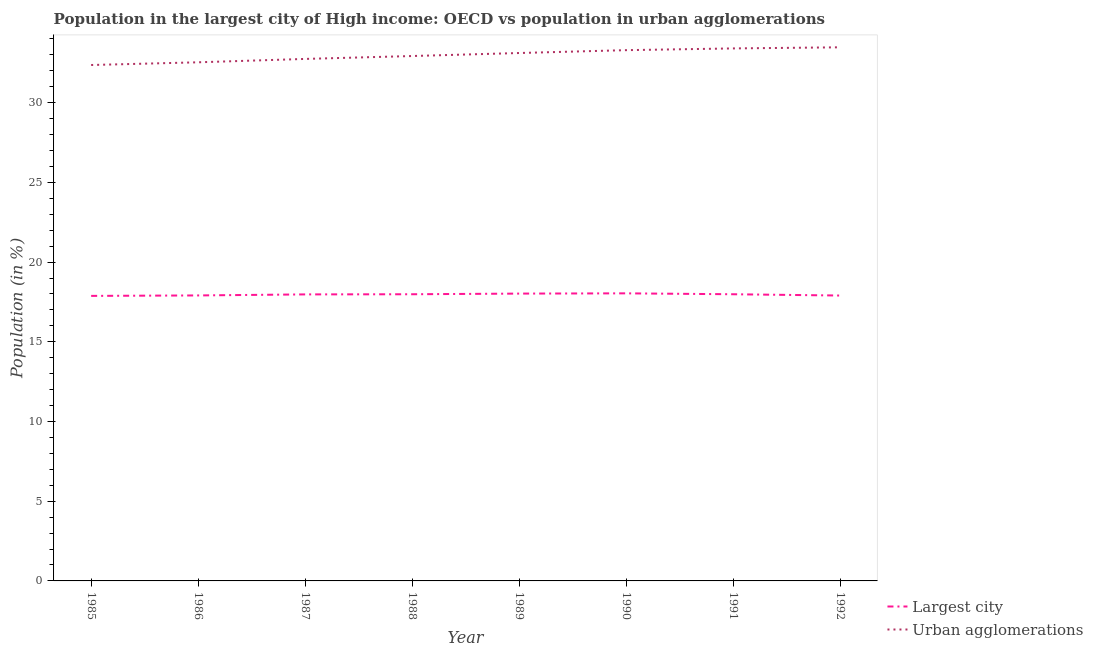Is the number of lines equal to the number of legend labels?
Provide a short and direct response. Yes. What is the population in urban agglomerations in 1985?
Ensure brevity in your answer.  32.36. Across all years, what is the maximum population in urban agglomerations?
Give a very brief answer. 33.48. Across all years, what is the minimum population in the largest city?
Provide a succinct answer. 17.88. What is the total population in the largest city in the graph?
Provide a succinct answer. 143.7. What is the difference between the population in urban agglomerations in 1989 and that in 1991?
Provide a succinct answer. -0.29. What is the difference between the population in the largest city in 1991 and the population in urban agglomerations in 1985?
Your answer should be compact. -14.38. What is the average population in urban agglomerations per year?
Your response must be concise. 32.98. In the year 1990, what is the difference between the population in urban agglomerations and population in the largest city?
Ensure brevity in your answer.  15.26. In how many years, is the population in urban agglomerations greater than 29 %?
Offer a very short reply. 8. What is the ratio of the population in urban agglomerations in 1985 to that in 1988?
Your response must be concise. 0.98. Is the population in the largest city in 1986 less than that in 1988?
Provide a succinct answer. Yes. Is the difference between the population in the largest city in 1985 and 1991 greater than the difference between the population in urban agglomerations in 1985 and 1991?
Your answer should be compact. Yes. What is the difference between the highest and the second highest population in urban agglomerations?
Your response must be concise. 0.07. What is the difference between the highest and the lowest population in the largest city?
Your response must be concise. 0.16. In how many years, is the population in the largest city greater than the average population in the largest city taken over all years?
Offer a terse response. 5. Is the sum of the population in urban agglomerations in 1990 and 1992 greater than the maximum population in the largest city across all years?
Keep it short and to the point. Yes. Is the population in the largest city strictly greater than the population in urban agglomerations over the years?
Keep it short and to the point. No. Is the population in the largest city strictly less than the population in urban agglomerations over the years?
Provide a succinct answer. Yes. How many lines are there?
Provide a short and direct response. 2. Does the graph contain grids?
Your response must be concise. No. Where does the legend appear in the graph?
Provide a succinct answer. Bottom right. How many legend labels are there?
Keep it short and to the point. 2. How are the legend labels stacked?
Give a very brief answer. Vertical. What is the title of the graph?
Offer a very short reply. Population in the largest city of High income: OECD vs population in urban agglomerations. Does "Rural Population" appear as one of the legend labels in the graph?
Your response must be concise. No. What is the Population (in %) of Largest city in 1985?
Give a very brief answer. 17.88. What is the Population (in %) in Urban agglomerations in 1985?
Keep it short and to the point. 32.36. What is the Population (in %) of Largest city in 1986?
Your answer should be compact. 17.91. What is the Population (in %) of Urban agglomerations in 1986?
Give a very brief answer. 32.53. What is the Population (in %) of Largest city in 1987?
Give a very brief answer. 17.97. What is the Population (in %) of Urban agglomerations in 1987?
Ensure brevity in your answer.  32.75. What is the Population (in %) in Largest city in 1988?
Ensure brevity in your answer.  17.98. What is the Population (in %) of Urban agglomerations in 1988?
Ensure brevity in your answer.  32.93. What is the Population (in %) of Largest city in 1989?
Give a very brief answer. 18.02. What is the Population (in %) of Urban agglomerations in 1989?
Provide a short and direct response. 33.12. What is the Population (in %) in Largest city in 1990?
Provide a succinct answer. 18.04. What is the Population (in %) in Urban agglomerations in 1990?
Your answer should be compact. 33.3. What is the Population (in %) in Largest city in 1991?
Give a very brief answer. 17.98. What is the Population (in %) in Urban agglomerations in 1991?
Offer a terse response. 33.41. What is the Population (in %) in Largest city in 1992?
Give a very brief answer. 17.9. What is the Population (in %) in Urban agglomerations in 1992?
Make the answer very short. 33.48. Across all years, what is the maximum Population (in %) in Largest city?
Make the answer very short. 18.04. Across all years, what is the maximum Population (in %) of Urban agglomerations?
Give a very brief answer. 33.48. Across all years, what is the minimum Population (in %) in Largest city?
Your answer should be compact. 17.88. Across all years, what is the minimum Population (in %) in Urban agglomerations?
Offer a very short reply. 32.36. What is the total Population (in %) of Largest city in the graph?
Provide a short and direct response. 143.7. What is the total Population (in %) in Urban agglomerations in the graph?
Your answer should be very brief. 263.87. What is the difference between the Population (in %) of Largest city in 1985 and that in 1986?
Ensure brevity in your answer.  -0.03. What is the difference between the Population (in %) of Urban agglomerations in 1985 and that in 1986?
Offer a very short reply. -0.17. What is the difference between the Population (in %) in Largest city in 1985 and that in 1987?
Give a very brief answer. -0.09. What is the difference between the Population (in %) in Urban agglomerations in 1985 and that in 1987?
Your response must be concise. -0.38. What is the difference between the Population (in %) of Largest city in 1985 and that in 1988?
Ensure brevity in your answer.  -0.1. What is the difference between the Population (in %) in Urban agglomerations in 1985 and that in 1988?
Provide a succinct answer. -0.56. What is the difference between the Population (in %) of Largest city in 1985 and that in 1989?
Provide a succinct answer. -0.14. What is the difference between the Population (in %) in Urban agglomerations in 1985 and that in 1989?
Provide a short and direct response. -0.75. What is the difference between the Population (in %) in Largest city in 1985 and that in 1990?
Your answer should be very brief. -0.16. What is the difference between the Population (in %) of Urban agglomerations in 1985 and that in 1990?
Your response must be concise. -0.93. What is the difference between the Population (in %) of Largest city in 1985 and that in 1991?
Offer a very short reply. -0.1. What is the difference between the Population (in %) in Urban agglomerations in 1985 and that in 1991?
Your response must be concise. -1.04. What is the difference between the Population (in %) in Largest city in 1985 and that in 1992?
Provide a succinct answer. -0.02. What is the difference between the Population (in %) of Urban agglomerations in 1985 and that in 1992?
Your answer should be compact. -1.11. What is the difference between the Population (in %) of Largest city in 1986 and that in 1987?
Give a very brief answer. -0.06. What is the difference between the Population (in %) of Urban agglomerations in 1986 and that in 1987?
Keep it short and to the point. -0.21. What is the difference between the Population (in %) of Largest city in 1986 and that in 1988?
Your answer should be compact. -0.07. What is the difference between the Population (in %) of Urban agglomerations in 1986 and that in 1988?
Your answer should be very brief. -0.39. What is the difference between the Population (in %) of Largest city in 1986 and that in 1989?
Keep it short and to the point. -0.12. What is the difference between the Population (in %) of Urban agglomerations in 1986 and that in 1989?
Provide a short and direct response. -0.58. What is the difference between the Population (in %) in Largest city in 1986 and that in 1990?
Provide a short and direct response. -0.13. What is the difference between the Population (in %) of Urban agglomerations in 1986 and that in 1990?
Offer a terse response. -0.76. What is the difference between the Population (in %) of Largest city in 1986 and that in 1991?
Your response must be concise. -0.07. What is the difference between the Population (in %) of Urban agglomerations in 1986 and that in 1991?
Provide a succinct answer. -0.87. What is the difference between the Population (in %) of Largest city in 1986 and that in 1992?
Provide a succinct answer. 0.01. What is the difference between the Population (in %) of Urban agglomerations in 1986 and that in 1992?
Offer a very short reply. -0.94. What is the difference between the Population (in %) of Largest city in 1987 and that in 1988?
Give a very brief answer. -0.01. What is the difference between the Population (in %) in Urban agglomerations in 1987 and that in 1988?
Keep it short and to the point. -0.18. What is the difference between the Population (in %) in Largest city in 1987 and that in 1989?
Offer a very short reply. -0.05. What is the difference between the Population (in %) of Urban agglomerations in 1987 and that in 1989?
Provide a succinct answer. -0.37. What is the difference between the Population (in %) of Largest city in 1987 and that in 1990?
Your answer should be compact. -0.07. What is the difference between the Population (in %) of Urban agglomerations in 1987 and that in 1990?
Keep it short and to the point. -0.55. What is the difference between the Population (in %) of Largest city in 1987 and that in 1991?
Your answer should be compact. -0.01. What is the difference between the Population (in %) of Urban agglomerations in 1987 and that in 1991?
Your answer should be compact. -0.66. What is the difference between the Population (in %) in Largest city in 1987 and that in 1992?
Offer a terse response. 0.07. What is the difference between the Population (in %) of Urban agglomerations in 1987 and that in 1992?
Offer a terse response. -0.73. What is the difference between the Population (in %) of Largest city in 1988 and that in 1989?
Your answer should be compact. -0.04. What is the difference between the Population (in %) of Urban agglomerations in 1988 and that in 1989?
Make the answer very short. -0.19. What is the difference between the Population (in %) in Largest city in 1988 and that in 1990?
Offer a terse response. -0.06. What is the difference between the Population (in %) in Urban agglomerations in 1988 and that in 1990?
Your response must be concise. -0.37. What is the difference between the Population (in %) of Largest city in 1988 and that in 1991?
Keep it short and to the point. -0. What is the difference between the Population (in %) of Urban agglomerations in 1988 and that in 1991?
Your answer should be very brief. -0.48. What is the difference between the Population (in %) in Largest city in 1988 and that in 1992?
Give a very brief answer. 0.08. What is the difference between the Population (in %) of Urban agglomerations in 1988 and that in 1992?
Provide a short and direct response. -0.55. What is the difference between the Population (in %) in Largest city in 1989 and that in 1990?
Provide a short and direct response. -0.02. What is the difference between the Population (in %) of Urban agglomerations in 1989 and that in 1990?
Provide a succinct answer. -0.18. What is the difference between the Population (in %) of Largest city in 1989 and that in 1991?
Keep it short and to the point. 0.04. What is the difference between the Population (in %) in Urban agglomerations in 1989 and that in 1991?
Make the answer very short. -0.29. What is the difference between the Population (in %) of Largest city in 1989 and that in 1992?
Ensure brevity in your answer.  0.12. What is the difference between the Population (in %) in Urban agglomerations in 1989 and that in 1992?
Keep it short and to the point. -0.36. What is the difference between the Population (in %) of Largest city in 1990 and that in 1991?
Your answer should be very brief. 0.06. What is the difference between the Population (in %) of Urban agglomerations in 1990 and that in 1991?
Provide a succinct answer. -0.11. What is the difference between the Population (in %) of Largest city in 1990 and that in 1992?
Provide a succinct answer. 0.14. What is the difference between the Population (in %) in Urban agglomerations in 1990 and that in 1992?
Your answer should be compact. -0.18. What is the difference between the Population (in %) of Largest city in 1991 and that in 1992?
Keep it short and to the point. 0.08. What is the difference between the Population (in %) of Urban agglomerations in 1991 and that in 1992?
Your answer should be very brief. -0.07. What is the difference between the Population (in %) in Largest city in 1985 and the Population (in %) in Urban agglomerations in 1986?
Provide a short and direct response. -14.65. What is the difference between the Population (in %) of Largest city in 1985 and the Population (in %) of Urban agglomerations in 1987?
Your answer should be compact. -14.87. What is the difference between the Population (in %) of Largest city in 1985 and the Population (in %) of Urban agglomerations in 1988?
Your answer should be compact. -15.05. What is the difference between the Population (in %) of Largest city in 1985 and the Population (in %) of Urban agglomerations in 1989?
Ensure brevity in your answer.  -15.24. What is the difference between the Population (in %) of Largest city in 1985 and the Population (in %) of Urban agglomerations in 1990?
Make the answer very short. -15.42. What is the difference between the Population (in %) in Largest city in 1985 and the Population (in %) in Urban agglomerations in 1991?
Keep it short and to the point. -15.52. What is the difference between the Population (in %) in Largest city in 1985 and the Population (in %) in Urban agglomerations in 1992?
Your response must be concise. -15.59. What is the difference between the Population (in %) in Largest city in 1986 and the Population (in %) in Urban agglomerations in 1987?
Your response must be concise. -14.84. What is the difference between the Population (in %) in Largest city in 1986 and the Population (in %) in Urban agglomerations in 1988?
Ensure brevity in your answer.  -15.02. What is the difference between the Population (in %) of Largest city in 1986 and the Population (in %) of Urban agglomerations in 1989?
Your answer should be compact. -15.21. What is the difference between the Population (in %) in Largest city in 1986 and the Population (in %) in Urban agglomerations in 1990?
Keep it short and to the point. -15.39. What is the difference between the Population (in %) in Largest city in 1986 and the Population (in %) in Urban agglomerations in 1991?
Your response must be concise. -15.5. What is the difference between the Population (in %) of Largest city in 1986 and the Population (in %) of Urban agglomerations in 1992?
Make the answer very short. -15.57. What is the difference between the Population (in %) of Largest city in 1987 and the Population (in %) of Urban agglomerations in 1988?
Your answer should be very brief. -14.95. What is the difference between the Population (in %) of Largest city in 1987 and the Population (in %) of Urban agglomerations in 1989?
Your answer should be very brief. -15.14. What is the difference between the Population (in %) of Largest city in 1987 and the Population (in %) of Urban agglomerations in 1990?
Ensure brevity in your answer.  -15.32. What is the difference between the Population (in %) of Largest city in 1987 and the Population (in %) of Urban agglomerations in 1991?
Your answer should be compact. -15.43. What is the difference between the Population (in %) in Largest city in 1987 and the Population (in %) in Urban agglomerations in 1992?
Provide a short and direct response. -15.5. What is the difference between the Population (in %) of Largest city in 1988 and the Population (in %) of Urban agglomerations in 1989?
Your answer should be compact. -15.13. What is the difference between the Population (in %) of Largest city in 1988 and the Population (in %) of Urban agglomerations in 1990?
Your answer should be compact. -15.31. What is the difference between the Population (in %) of Largest city in 1988 and the Population (in %) of Urban agglomerations in 1991?
Ensure brevity in your answer.  -15.42. What is the difference between the Population (in %) in Largest city in 1988 and the Population (in %) in Urban agglomerations in 1992?
Your answer should be very brief. -15.49. What is the difference between the Population (in %) of Largest city in 1989 and the Population (in %) of Urban agglomerations in 1990?
Your response must be concise. -15.27. What is the difference between the Population (in %) in Largest city in 1989 and the Population (in %) in Urban agglomerations in 1991?
Your answer should be compact. -15.38. What is the difference between the Population (in %) of Largest city in 1989 and the Population (in %) of Urban agglomerations in 1992?
Offer a very short reply. -15.45. What is the difference between the Population (in %) of Largest city in 1990 and the Population (in %) of Urban agglomerations in 1991?
Make the answer very short. -15.36. What is the difference between the Population (in %) of Largest city in 1990 and the Population (in %) of Urban agglomerations in 1992?
Provide a succinct answer. -15.43. What is the difference between the Population (in %) in Largest city in 1991 and the Population (in %) in Urban agglomerations in 1992?
Give a very brief answer. -15.49. What is the average Population (in %) in Largest city per year?
Ensure brevity in your answer.  17.96. What is the average Population (in %) of Urban agglomerations per year?
Keep it short and to the point. 32.98. In the year 1985, what is the difference between the Population (in %) of Largest city and Population (in %) of Urban agglomerations?
Make the answer very short. -14.48. In the year 1986, what is the difference between the Population (in %) in Largest city and Population (in %) in Urban agglomerations?
Offer a very short reply. -14.62. In the year 1987, what is the difference between the Population (in %) of Largest city and Population (in %) of Urban agglomerations?
Offer a very short reply. -14.77. In the year 1988, what is the difference between the Population (in %) in Largest city and Population (in %) in Urban agglomerations?
Offer a very short reply. -14.94. In the year 1989, what is the difference between the Population (in %) in Largest city and Population (in %) in Urban agglomerations?
Keep it short and to the point. -15.09. In the year 1990, what is the difference between the Population (in %) in Largest city and Population (in %) in Urban agglomerations?
Your response must be concise. -15.26. In the year 1991, what is the difference between the Population (in %) in Largest city and Population (in %) in Urban agglomerations?
Give a very brief answer. -15.42. In the year 1992, what is the difference between the Population (in %) in Largest city and Population (in %) in Urban agglomerations?
Ensure brevity in your answer.  -15.57. What is the ratio of the Population (in %) of Largest city in 1985 to that in 1986?
Offer a very short reply. 1. What is the ratio of the Population (in %) of Urban agglomerations in 1985 to that in 1986?
Provide a short and direct response. 0.99. What is the ratio of the Population (in %) of Largest city in 1985 to that in 1987?
Your answer should be very brief. 0.99. What is the ratio of the Population (in %) of Urban agglomerations in 1985 to that in 1987?
Give a very brief answer. 0.99. What is the ratio of the Population (in %) in Urban agglomerations in 1985 to that in 1988?
Give a very brief answer. 0.98. What is the ratio of the Population (in %) of Largest city in 1985 to that in 1989?
Give a very brief answer. 0.99. What is the ratio of the Population (in %) of Urban agglomerations in 1985 to that in 1989?
Your answer should be compact. 0.98. What is the ratio of the Population (in %) in Largest city in 1985 to that in 1990?
Your response must be concise. 0.99. What is the ratio of the Population (in %) in Largest city in 1985 to that in 1991?
Keep it short and to the point. 0.99. What is the ratio of the Population (in %) of Urban agglomerations in 1985 to that in 1991?
Make the answer very short. 0.97. What is the ratio of the Population (in %) of Largest city in 1985 to that in 1992?
Ensure brevity in your answer.  1. What is the ratio of the Population (in %) in Urban agglomerations in 1985 to that in 1992?
Give a very brief answer. 0.97. What is the ratio of the Population (in %) in Largest city in 1986 to that in 1987?
Provide a succinct answer. 1. What is the ratio of the Population (in %) in Urban agglomerations in 1986 to that in 1987?
Offer a terse response. 0.99. What is the ratio of the Population (in %) of Urban agglomerations in 1986 to that in 1989?
Offer a terse response. 0.98. What is the ratio of the Population (in %) of Urban agglomerations in 1986 to that in 1990?
Provide a succinct answer. 0.98. What is the ratio of the Population (in %) of Largest city in 1986 to that in 1991?
Offer a terse response. 1. What is the ratio of the Population (in %) of Urban agglomerations in 1986 to that in 1991?
Provide a short and direct response. 0.97. What is the ratio of the Population (in %) in Urban agglomerations in 1986 to that in 1992?
Offer a terse response. 0.97. What is the ratio of the Population (in %) in Largest city in 1987 to that in 1988?
Ensure brevity in your answer.  1. What is the ratio of the Population (in %) in Largest city in 1987 to that in 1989?
Offer a very short reply. 1. What is the ratio of the Population (in %) of Urban agglomerations in 1987 to that in 1989?
Provide a short and direct response. 0.99. What is the ratio of the Population (in %) in Largest city in 1987 to that in 1990?
Your answer should be very brief. 1. What is the ratio of the Population (in %) in Urban agglomerations in 1987 to that in 1990?
Ensure brevity in your answer.  0.98. What is the ratio of the Population (in %) in Urban agglomerations in 1987 to that in 1991?
Offer a terse response. 0.98. What is the ratio of the Population (in %) of Urban agglomerations in 1987 to that in 1992?
Keep it short and to the point. 0.98. What is the ratio of the Population (in %) in Urban agglomerations in 1988 to that in 1989?
Offer a very short reply. 0.99. What is the ratio of the Population (in %) of Urban agglomerations in 1988 to that in 1990?
Make the answer very short. 0.99. What is the ratio of the Population (in %) in Urban agglomerations in 1988 to that in 1991?
Provide a short and direct response. 0.99. What is the ratio of the Population (in %) of Largest city in 1988 to that in 1992?
Provide a succinct answer. 1. What is the ratio of the Population (in %) in Urban agglomerations in 1988 to that in 1992?
Provide a short and direct response. 0.98. What is the ratio of the Population (in %) in Largest city in 1989 to that in 1990?
Your answer should be compact. 1. What is the ratio of the Population (in %) in Urban agglomerations in 1989 to that in 1991?
Keep it short and to the point. 0.99. What is the ratio of the Population (in %) in Largest city in 1989 to that in 1992?
Offer a terse response. 1.01. What is the ratio of the Population (in %) of Urban agglomerations in 1989 to that in 1992?
Provide a short and direct response. 0.99. What is the ratio of the Population (in %) in Largest city in 1990 to that in 1991?
Offer a terse response. 1. What is the ratio of the Population (in %) in Urban agglomerations in 1990 to that in 1991?
Ensure brevity in your answer.  1. What is the ratio of the Population (in %) in Largest city in 1990 to that in 1992?
Provide a succinct answer. 1.01. What is the ratio of the Population (in %) in Urban agglomerations in 1990 to that in 1992?
Give a very brief answer. 0.99. What is the ratio of the Population (in %) in Largest city in 1991 to that in 1992?
Your answer should be very brief. 1. What is the difference between the highest and the second highest Population (in %) in Largest city?
Provide a short and direct response. 0.02. What is the difference between the highest and the second highest Population (in %) in Urban agglomerations?
Your answer should be very brief. 0.07. What is the difference between the highest and the lowest Population (in %) in Largest city?
Your answer should be very brief. 0.16. What is the difference between the highest and the lowest Population (in %) in Urban agglomerations?
Your response must be concise. 1.11. 